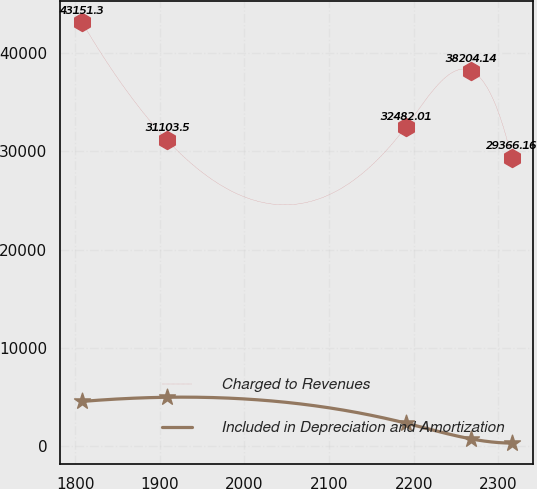Convert chart. <chart><loc_0><loc_0><loc_500><loc_500><line_chart><ecel><fcel>Charged to Revenues<fcel>Included in Depreciation and Amortization<nl><fcel>1807.81<fcel>43151.3<fcel>4573.88<nl><fcel>1908.9<fcel>31103.5<fcel>5001.51<nl><fcel>2190.66<fcel>32482<fcel>2374.19<nl><fcel>2267.72<fcel>38204.1<fcel>770.06<nl><fcel>2315.79<fcel>29366.2<fcel>342.43<nl></chart> 